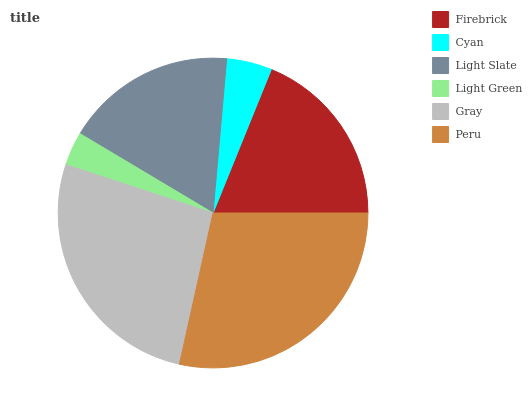Is Light Green the minimum?
Answer yes or no. Yes. Is Peru the maximum?
Answer yes or no. Yes. Is Cyan the minimum?
Answer yes or no. No. Is Cyan the maximum?
Answer yes or no. No. Is Firebrick greater than Cyan?
Answer yes or no. Yes. Is Cyan less than Firebrick?
Answer yes or no. Yes. Is Cyan greater than Firebrick?
Answer yes or no. No. Is Firebrick less than Cyan?
Answer yes or no. No. Is Firebrick the high median?
Answer yes or no. Yes. Is Light Slate the low median?
Answer yes or no. Yes. Is Light Green the high median?
Answer yes or no. No. Is Light Green the low median?
Answer yes or no. No. 